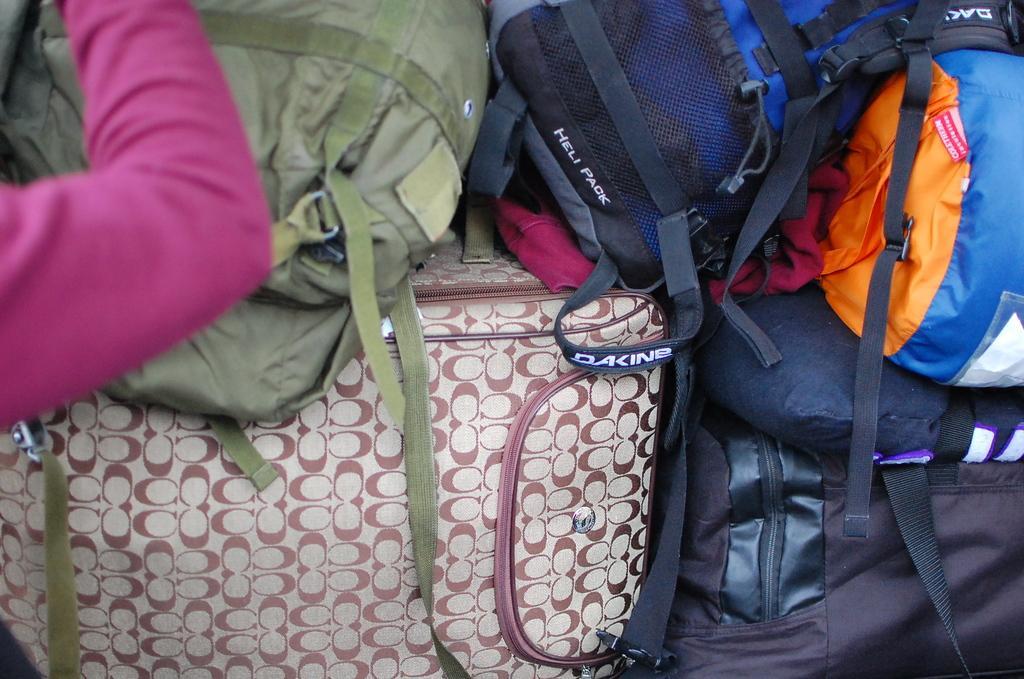Please provide a concise description of this image. In this image I can see many bags and the person's hand. 